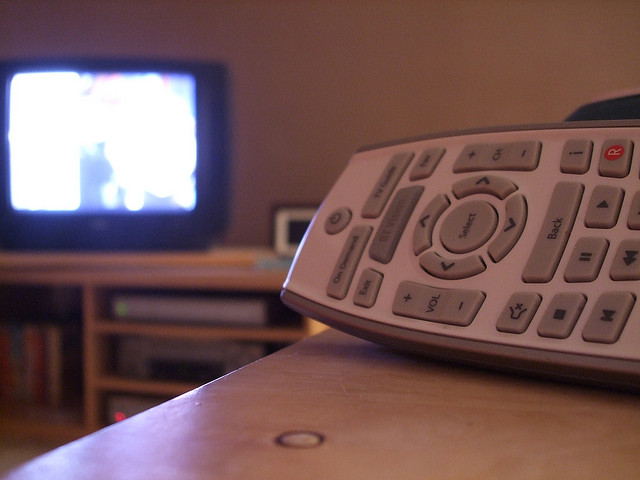<image>What character is on the TV? It is unclear what character is on the TV, the image is not clear. What character is on the TV? It is unknown what character is on the TV. The image is not clear. 